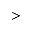Convert formula to latex. <formula><loc_0><loc_0><loc_500><loc_500>></formula> 